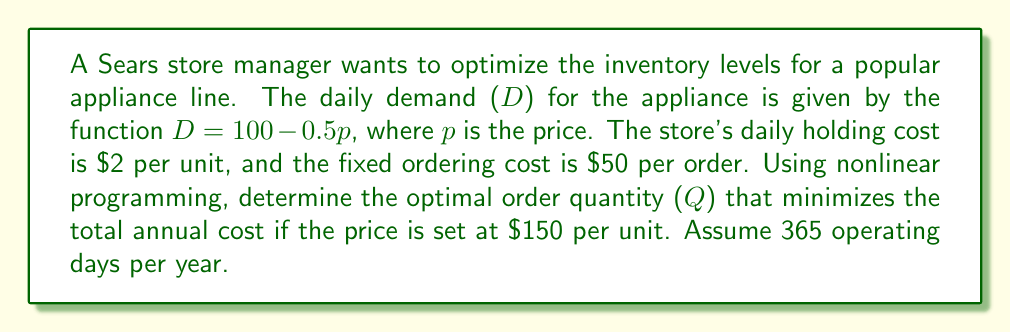Could you help me with this problem? Let's approach this step-by-step using nonlinear programming:

1. First, we need to determine the daily demand:
   $D = 100 - 0.5p = 100 - 0.5(150) = 25$ units per day

2. The annual demand (A) is:
   $A = 25 \times 365 = 9,125$ units per year

3. We'll use the Economic Order Quantity (EOQ) model, which is a nonlinear model. The total annual cost (TC) function is:

   $TC = \frac{A}{Q} \times S + \frac{Q}{2} \times H + pA$

   Where:
   - Q is the order quantity (our decision variable)
   - S is the fixed ordering cost ($50)
   - H is the annual holding cost per unit ($2 \times 365 = \$730)
   - p is the price per unit ($150)
   - A is the annual demand (9,125)

4. Substituting the values:

   $TC = \frac{9,125}{Q} \times 50 + \frac{Q}{2} \times 730 + 150 \times 9,125$

5. To find the optimal Q, we differentiate TC with respect to Q and set it to zero:

   $\frac{dTC}{dQ} = -\frac{9,125 \times 50}{Q^2} + \frac{730}{2} = 0$

6. Solving for Q:

   $\frac{9,125 \times 50}{Q^2} = \frac{730}{2}$
   $Q^2 = \frac{9,125 \times 50 \times 2}{730}$
   $Q = \sqrt{\frac{9,125 \times 100}{730}} \approx 157.95$

7. Since Q must be a whole number, we round to 158 units.
Answer: 158 units 